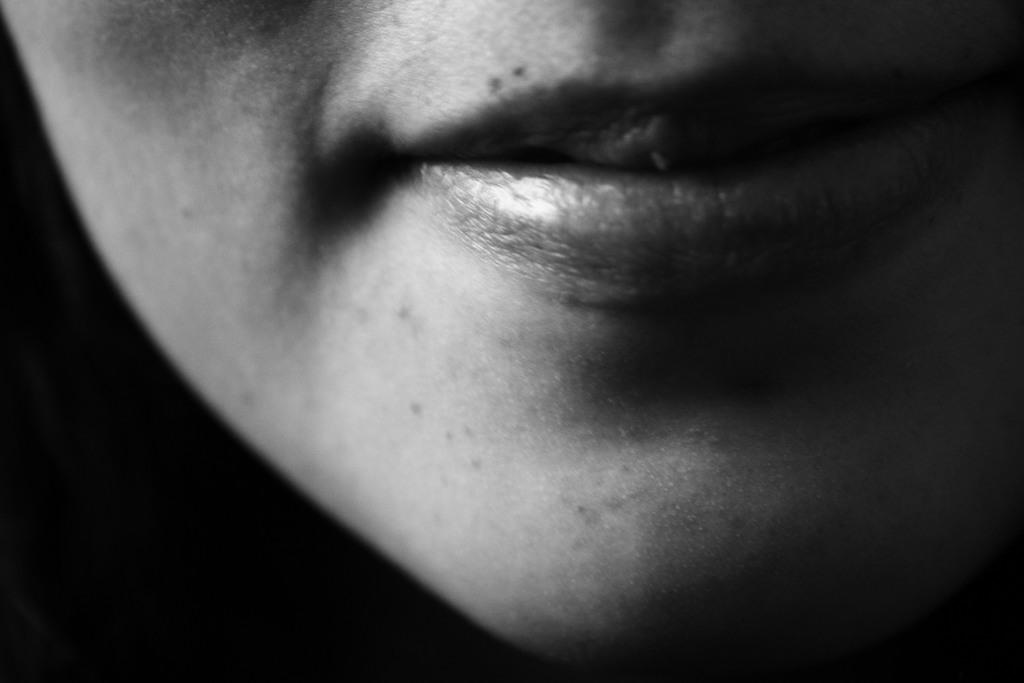What part of the body is visible in the image? The image contains a person's mouth. What color scheme is used in the image? The image is black and white in color. How many branches can be seen growing from the person's mouth in the image? There are no branches visible in the image, as it only contains a person's mouth. What type of insect is crawling on the person's lips in the image? There are no insects present in the image; it only contains a person's mouth. 